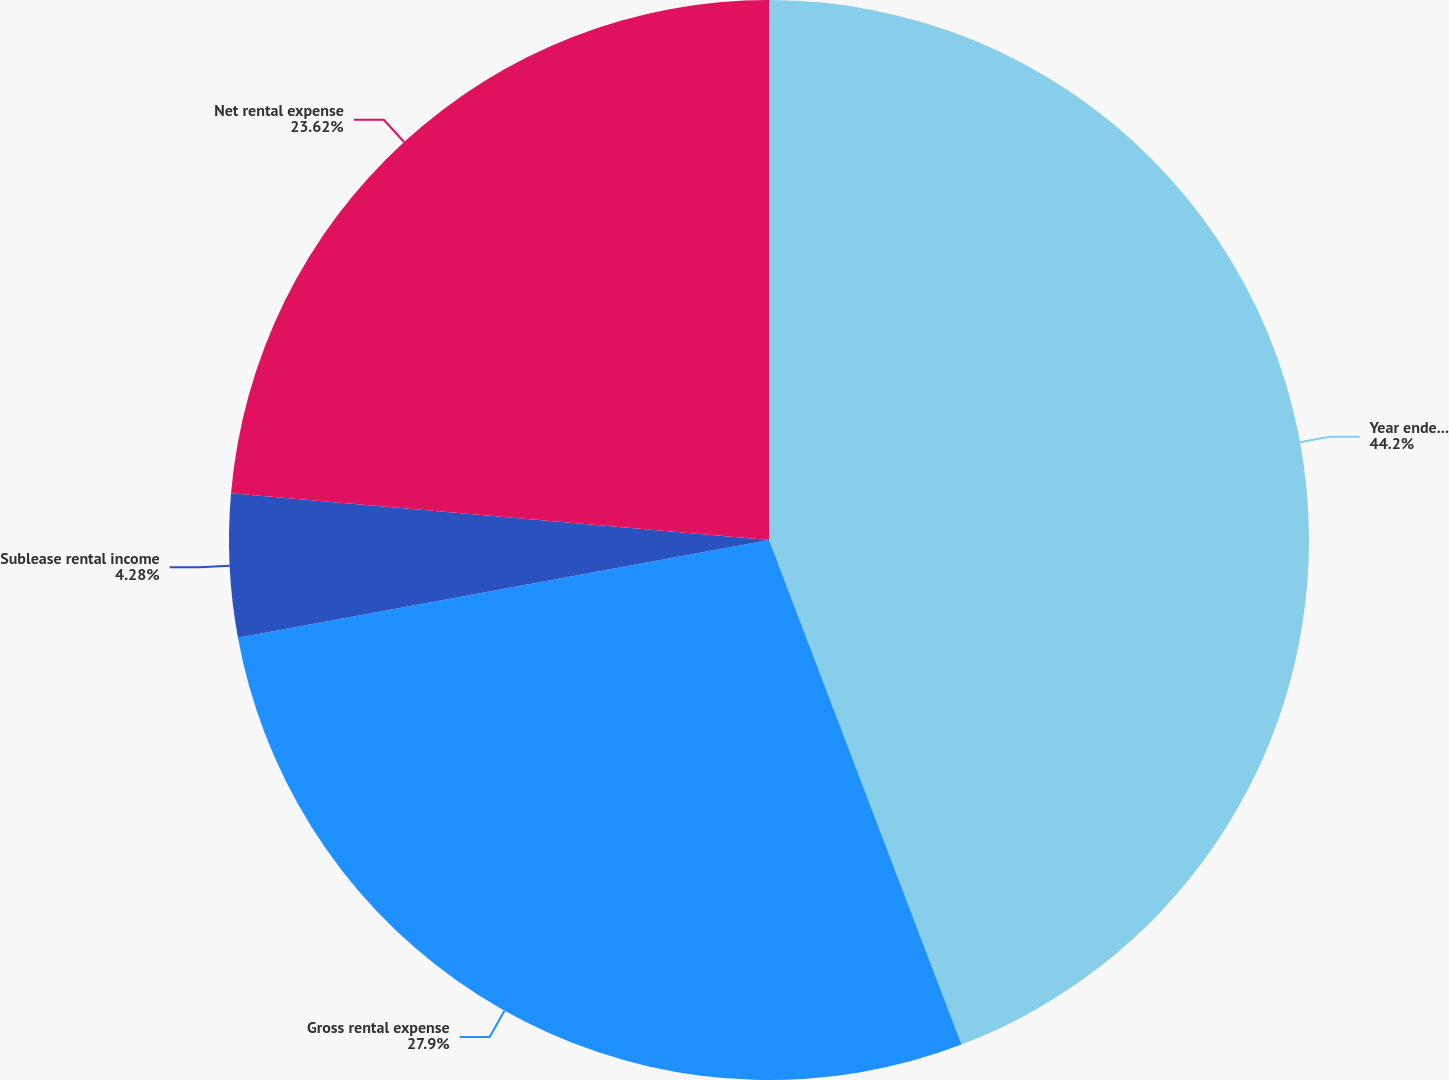<chart> <loc_0><loc_0><loc_500><loc_500><pie_chart><fcel>Year ended December 31 (in<fcel>Gross rental expense<fcel>Sublease rental income<fcel>Net rental expense<nl><fcel>44.2%<fcel>27.9%<fcel>4.28%<fcel>23.62%<nl></chart> 